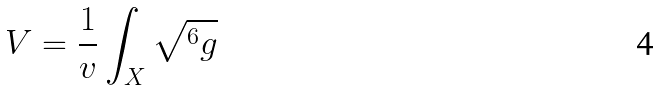<formula> <loc_0><loc_0><loc_500><loc_500>V = \frac { 1 } { v } \int _ { X } \sqrt { ^ { 6 } g }</formula> 